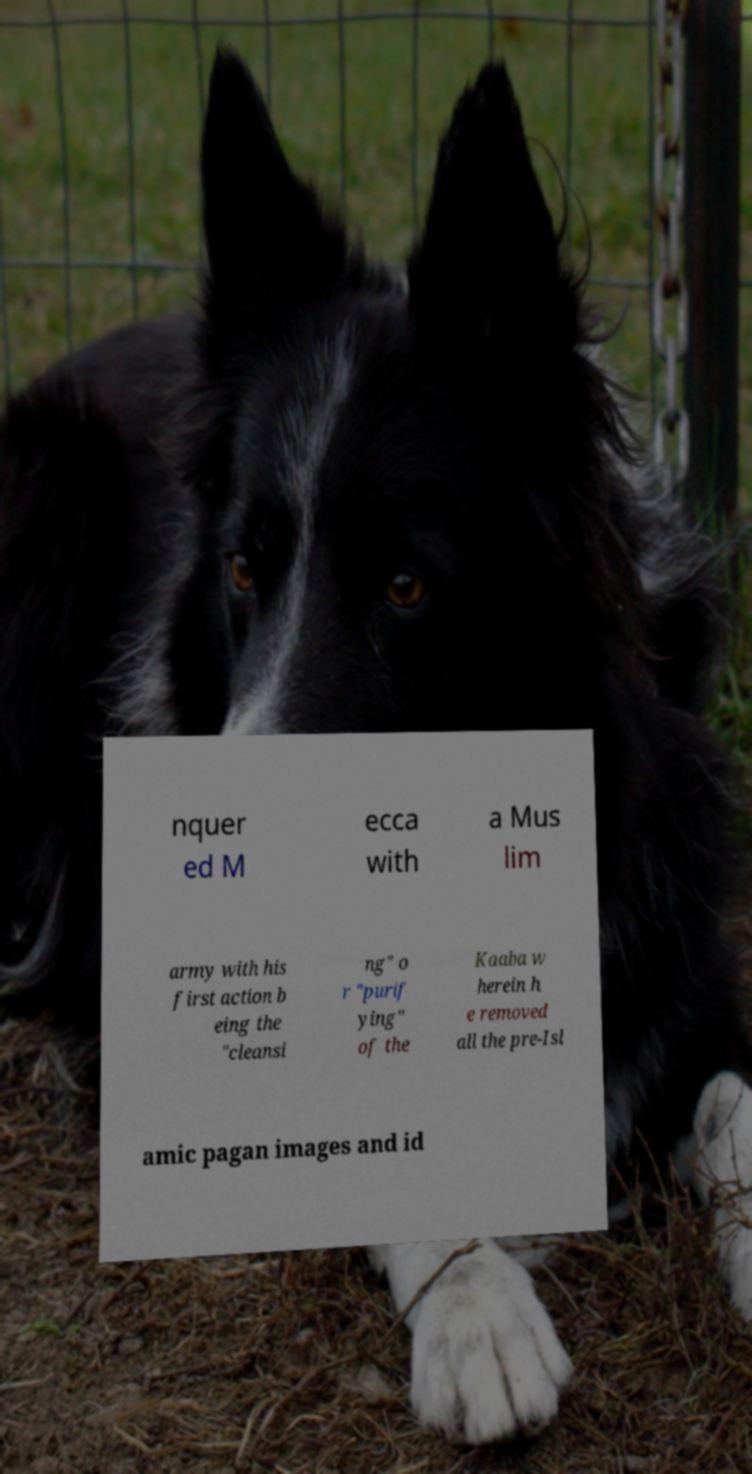Could you extract and type out the text from this image? nquer ed M ecca with a Mus lim army with his first action b eing the "cleansi ng" o r "purif ying" of the Kaaba w herein h e removed all the pre-Isl amic pagan images and id 